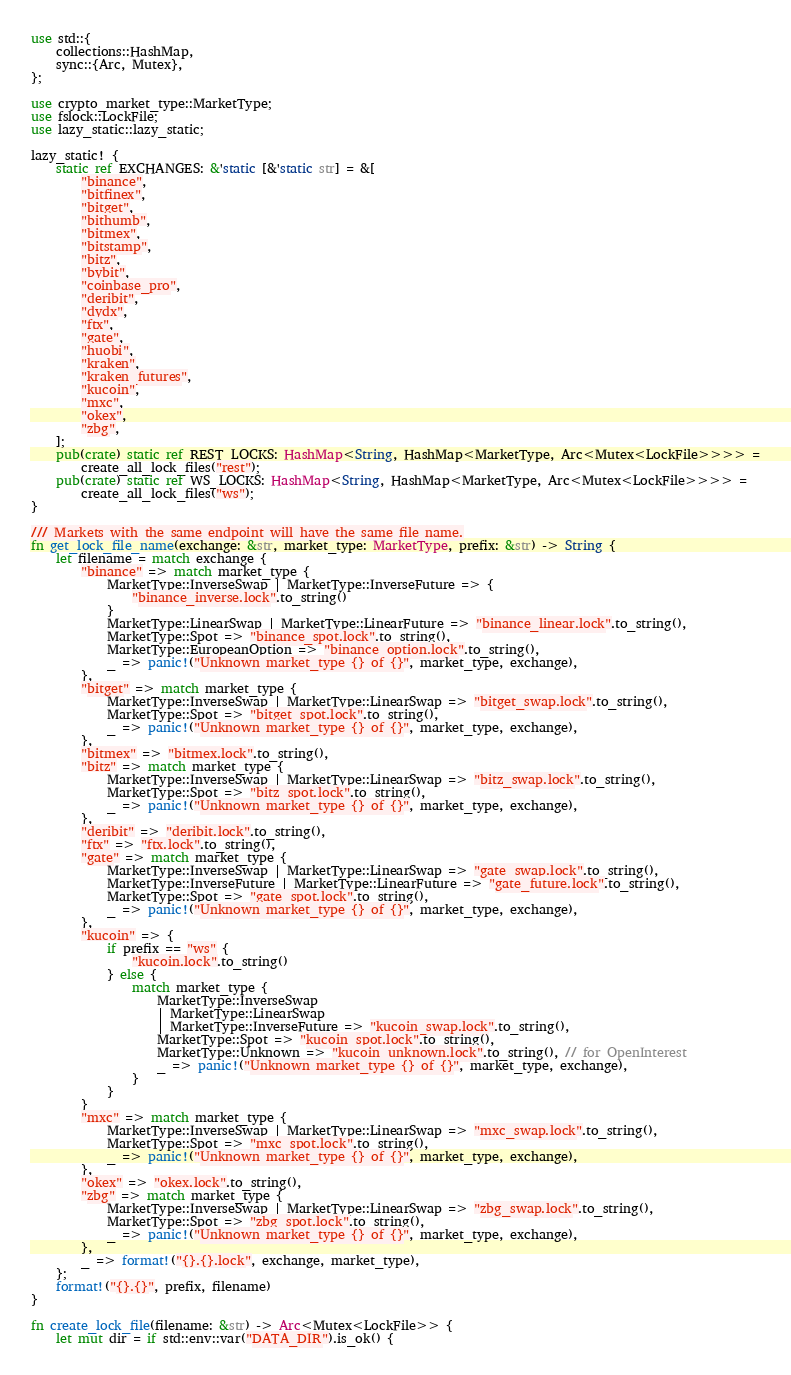Convert code to text. <code><loc_0><loc_0><loc_500><loc_500><_Rust_>use std::{
    collections::HashMap,
    sync::{Arc, Mutex},
};

use crypto_market_type::MarketType;
use fslock::LockFile;
use lazy_static::lazy_static;

lazy_static! {
    static ref EXCHANGES: &'static [&'static str] = &[
        "binance",
        "bitfinex",
        "bitget",
        "bithumb",
        "bitmex",
        "bitstamp",
        "bitz",
        "bybit",
        "coinbase_pro",
        "deribit",
        "dydx",
        "ftx",
        "gate",
        "huobi",
        "kraken",
        "kraken_futures",
        "kucoin",
        "mxc",
        "okex",
        "zbg",
    ];
    pub(crate) static ref REST_LOCKS: HashMap<String, HashMap<MarketType, Arc<Mutex<LockFile>>>> =
        create_all_lock_files("rest");
    pub(crate) static ref WS_LOCKS: HashMap<String, HashMap<MarketType, Arc<Mutex<LockFile>>>> =
        create_all_lock_files("ws");
}

/// Markets with the same endpoint will have the same file name.
fn get_lock_file_name(exchange: &str, market_type: MarketType, prefix: &str) -> String {
    let filename = match exchange {
        "binance" => match market_type {
            MarketType::InverseSwap | MarketType::InverseFuture => {
                "binance_inverse.lock".to_string()
            }
            MarketType::LinearSwap | MarketType::LinearFuture => "binance_linear.lock".to_string(),
            MarketType::Spot => "binance_spot.lock".to_string(),
            MarketType::EuropeanOption => "binance_option.lock".to_string(),
            _ => panic!("Unknown market_type {} of {}", market_type, exchange),
        },
        "bitget" => match market_type {
            MarketType::InverseSwap | MarketType::LinearSwap => "bitget_swap.lock".to_string(),
            MarketType::Spot => "bitget_spot.lock".to_string(),
            _ => panic!("Unknown market_type {} of {}", market_type, exchange),
        },
        "bitmex" => "bitmex.lock".to_string(),
        "bitz" => match market_type {
            MarketType::InverseSwap | MarketType::LinearSwap => "bitz_swap.lock".to_string(),
            MarketType::Spot => "bitz_spot.lock".to_string(),
            _ => panic!("Unknown market_type {} of {}", market_type, exchange),
        },
        "deribit" => "deribit.lock".to_string(),
        "ftx" => "ftx.lock".to_string(),
        "gate" => match market_type {
            MarketType::InverseSwap | MarketType::LinearSwap => "gate_swap.lock".to_string(),
            MarketType::InverseFuture | MarketType::LinearFuture => "gate_future.lock".to_string(),
            MarketType::Spot => "gate_spot.lock".to_string(),
            _ => panic!("Unknown market_type {} of {}", market_type, exchange),
        },
        "kucoin" => {
            if prefix == "ws" {
                "kucoin.lock".to_string()
            } else {
                match market_type {
                    MarketType::InverseSwap
                    | MarketType::LinearSwap
                    | MarketType::InverseFuture => "kucoin_swap.lock".to_string(),
                    MarketType::Spot => "kucoin_spot.lock".to_string(),
                    MarketType::Unknown => "kucoin_unknown.lock".to_string(), // for OpenInterest
                    _ => panic!("Unknown market_type {} of {}", market_type, exchange),
                }
            }
        }
        "mxc" => match market_type {
            MarketType::InverseSwap | MarketType::LinearSwap => "mxc_swap.lock".to_string(),
            MarketType::Spot => "mxc_spot.lock".to_string(),
            _ => panic!("Unknown market_type {} of {}", market_type, exchange),
        },
        "okex" => "okex.lock".to_string(),
        "zbg" => match market_type {
            MarketType::InverseSwap | MarketType::LinearSwap => "zbg_swap.lock".to_string(),
            MarketType::Spot => "zbg_spot.lock".to_string(),
            _ => panic!("Unknown market_type {} of {}", market_type, exchange),
        },
        _ => format!("{}.{}.lock", exchange, market_type),
    };
    format!("{}.{}", prefix, filename)
}

fn create_lock_file(filename: &str) -> Arc<Mutex<LockFile>> {
    let mut dir = if std::env::var("DATA_DIR").is_ok() {</code> 